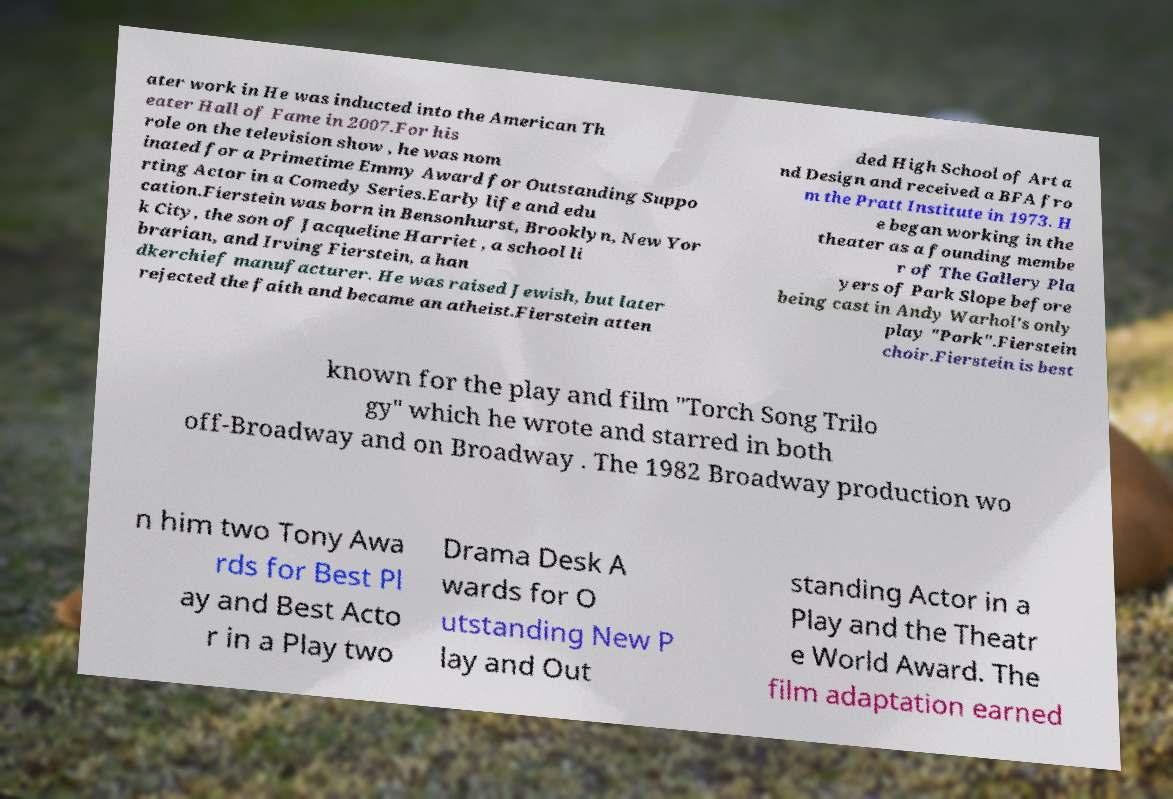For documentation purposes, I need the text within this image transcribed. Could you provide that? ater work in He was inducted into the American Th eater Hall of Fame in 2007.For his role on the television show , he was nom inated for a Primetime Emmy Award for Outstanding Suppo rting Actor in a Comedy Series.Early life and edu cation.Fierstein was born in Bensonhurst, Brooklyn, New Yor k City, the son of Jacqueline Harriet , a school li brarian, and Irving Fierstein, a han dkerchief manufacturer. He was raised Jewish, but later rejected the faith and became an atheist.Fierstein atten ded High School of Art a nd Design and received a BFA fro m the Pratt Institute in 1973. H e began working in the theater as a founding membe r of The Gallery Pla yers of Park Slope before being cast in Andy Warhol's only play "Pork".Fierstein choir.Fierstein is best known for the play and film "Torch Song Trilo gy" which he wrote and starred in both off-Broadway and on Broadway . The 1982 Broadway production wo n him two Tony Awa rds for Best Pl ay and Best Acto r in a Play two Drama Desk A wards for O utstanding New P lay and Out standing Actor in a Play and the Theatr e World Award. The film adaptation earned 